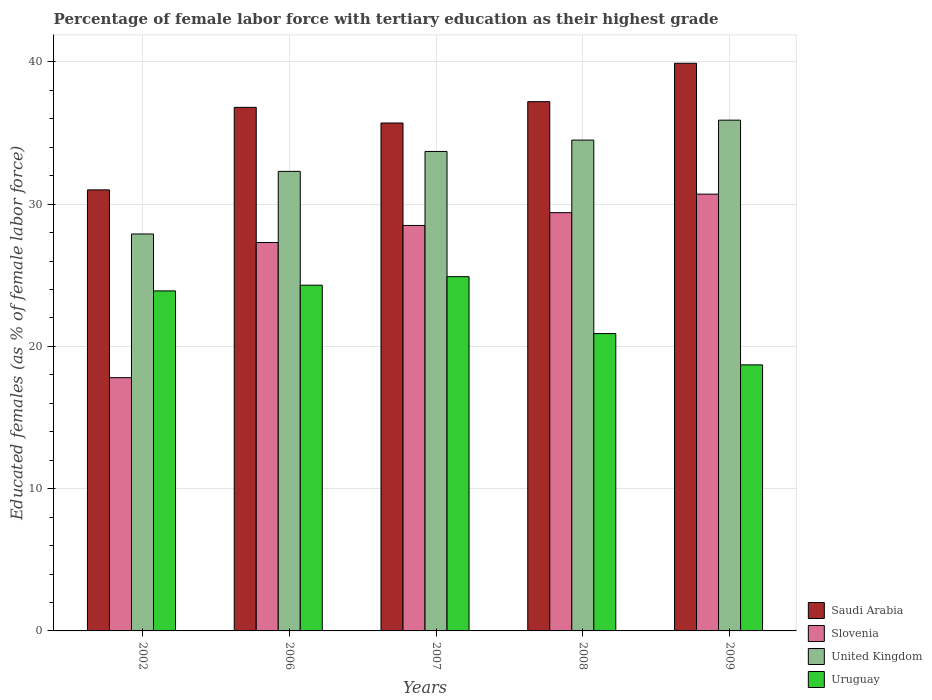How many groups of bars are there?
Provide a short and direct response. 5. Are the number of bars per tick equal to the number of legend labels?
Offer a terse response. Yes. What is the label of the 4th group of bars from the left?
Ensure brevity in your answer.  2008. What is the percentage of female labor force with tertiary education in Saudi Arabia in 2007?
Your answer should be compact. 35.7. Across all years, what is the maximum percentage of female labor force with tertiary education in Uruguay?
Your response must be concise. 24.9. In which year was the percentage of female labor force with tertiary education in United Kingdom maximum?
Provide a short and direct response. 2009. What is the total percentage of female labor force with tertiary education in Uruguay in the graph?
Offer a very short reply. 112.7. What is the difference between the percentage of female labor force with tertiary education in Saudi Arabia in 2007 and that in 2009?
Your response must be concise. -4.2. What is the difference between the percentage of female labor force with tertiary education in Saudi Arabia in 2008 and the percentage of female labor force with tertiary education in United Kingdom in 2006?
Give a very brief answer. 4.9. What is the average percentage of female labor force with tertiary education in Slovenia per year?
Ensure brevity in your answer.  26.74. What is the ratio of the percentage of female labor force with tertiary education in Uruguay in 2007 to that in 2008?
Offer a very short reply. 1.19. Is the percentage of female labor force with tertiary education in Uruguay in 2008 less than that in 2009?
Make the answer very short. No. Is the difference between the percentage of female labor force with tertiary education in Uruguay in 2006 and 2008 greater than the difference between the percentage of female labor force with tertiary education in United Kingdom in 2006 and 2008?
Make the answer very short. Yes. What is the difference between the highest and the second highest percentage of female labor force with tertiary education in Saudi Arabia?
Your answer should be very brief. 2.7. What is the difference between the highest and the lowest percentage of female labor force with tertiary education in United Kingdom?
Offer a very short reply. 8. What does the 2nd bar from the left in 2006 represents?
Provide a short and direct response. Slovenia. What does the 4th bar from the right in 2002 represents?
Provide a short and direct response. Saudi Arabia. Is it the case that in every year, the sum of the percentage of female labor force with tertiary education in Saudi Arabia and percentage of female labor force with tertiary education in Uruguay is greater than the percentage of female labor force with tertiary education in Slovenia?
Offer a very short reply. Yes. Are all the bars in the graph horizontal?
Provide a short and direct response. No. What is the difference between two consecutive major ticks on the Y-axis?
Ensure brevity in your answer.  10. Are the values on the major ticks of Y-axis written in scientific E-notation?
Your answer should be very brief. No. Does the graph contain grids?
Offer a very short reply. Yes. Where does the legend appear in the graph?
Keep it short and to the point. Bottom right. How are the legend labels stacked?
Your response must be concise. Vertical. What is the title of the graph?
Provide a short and direct response. Percentage of female labor force with tertiary education as their highest grade. Does "Marshall Islands" appear as one of the legend labels in the graph?
Offer a very short reply. No. What is the label or title of the Y-axis?
Make the answer very short. Educated females (as % of female labor force). What is the Educated females (as % of female labor force) of Saudi Arabia in 2002?
Your answer should be very brief. 31. What is the Educated females (as % of female labor force) of Slovenia in 2002?
Offer a very short reply. 17.8. What is the Educated females (as % of female labor force) of United Kingdom in 2002?
Offer a very short reply. 27.9. What is the Educated females (as % of female labor force) of Uruguay in 2002?
Your response must be concise. 23.9. What is the Educated females (as % of female labor force) in Saudi Arabia in 2006?
Keep it short and to the point. 36.8. What is the Educated females (as % of female labor force) in Slovenia in 2006?
Provide a succinct answer. 27.3. What is the Educated females (as % of female labor force) in United Kingdom in 2006?
Your answer should be very brief. 32.3. What is the Educated females (as % of female labor force) in Uruguay in 2006?
Make the answer very short. 24.3. What is the Educated females (as % of female labor force) of Saudi Arabia in 2007?
Ensure brevity in your answer.  35.7. What is the Educated females (as % of female labor force) of Slovenia in 2007?
Your answer should be compact. 28.5. What is the Educated females (as % of female labor force) of United Kingdom in 2007?
Provide a succinct answer. 33.7. What is the Educated females (as % of female labor force) of Uruguay in 2007?
Make the answer very short. 24.9. What is the Educated females (as % of female labor force) in Saudi Arabia in 2008?
Provide a succinct answer. 37.2. What is the Educated females (as % of female labor force) of Slovenia in 2008?
Your answer should be very brief. 29.4. What is the Educated females (as % of female labor force) of United Kingdom in 2008?
Provide a short and direct response. 34.5. What is the Educated females (as % of female labor force) of Uruguay in 2008?
Offer a very short reply. 20.9. What is the Educated females (as % of female labor force) in Saudi Arabia in 2009?
Your answer should be compact. 39.9. What is the Educated females (as % of female labor force) in Slovenia in 2009?
Your answer should be very brief. 30.7. What is the Educated females (as % of female labor force) of United Kingdom in 2009?
Keep it short and to the point. 35.9. What is the Educated females (as % of female labor force) in Uruguay in 2009?
Offer a terse response. 18.7. Across all years, what is the maximum Educated females (as % of female labor force) of Saudi Arabia?
Your response must be concise. 39.9. Across all years, what is the maximum Educated females (as % of female labor force) in Slovenia?
Provide a succinct answer. 30.7. Across all years, what is the maximum Educated females (as % of female labor force) in United Kingdom?
Provide a short and direct response. 35.9. Across all years, what is the maximum Educated females (as % of female labor force) in Uruguay?
Ensure brevity in your answer.  24.9. Across all years, what is the minimum Educated females (as % of female labor force) of Slovenia?
Offer a very short reply. 17.8. Across all years, what is the minimum Educated females (as % of female labor force) of United Kingdom?
Keep it short and to the point. 27.9. Across all years, what is the minimum Educated females (as % of female labor force) of Uruguay?
Offer a very short reply. 18.7. What is the total Educated females (as % of female labor force) in Saudi Arabia in the graph?
Offer a very short reply. 180.6. What is the total Educated females (as % of female labor force) in Slovenia in the graph?
Keep it short and to the point. 133.7. What is the total Educated females (as % of female labor force) in United Kingdom in the graph?
Offer a terse response. 164.3. What is the total Educated females (as % of female labor force) of Uruguay in the graph?
Ensure brevity in your answer.  112.7. What is the difference between the Educated females (as % of female labor force) in Saudi Arabia in 2002 and that in 2006?
Provide a short and direct response. -5.8. What is the difference between the Educated females (as % of female labor force) in Slovenia in 2002 and that in 2006?
Your answer should be compact. -9.5. What is the difference between the Educated females (as % of female labor force) in Uruguay in 2002 and that in 2006?
Give a very brief answer. -0.4. What is the difference between the Educated females (as % of female labor force) of Saudi Arabia in 2002 and that in 2007?
Provide a succinct answer. -4.7. What is the difference between the Educated females (as % of female labor force) in United Kingdom in 2002 and that in 2007?
Make the answer very short. -5.8. What is the difference between the Educated females (as % of female labor force) of United Kingdom in 2002 and that in 2008?
Offer a terse response. -6.6. What is the difference between the Educated females (as % of female labor force) of Uruguay in 2002 and that in 2008?
Your answer should be very brief. 3. What is the difference between the Educated females (as % of female labor force) of Saudi Arabia in 2006 and that in 2007?
Keep it short and to the point. 1.1. What is the difference between the Educated females (as % of female labor force) in Slovenia in 2006 and that in 2007?
Offer a terse response. -1.2. What is the difference between the Educated females (as % of female labor force) in United Kingdom in 2006 and that in 2008?
Offer a very short reply. -2.2. What is the difference between the Educated females (as % of female labor force) in Saudi Arabia in 2007 and that in 2008?
Offer a terse response. -1.5. What is the difference between the Educated females (as % of female labor force) in Slovenia in 2007 and that in 2008?
Your answer should be very brief. -0.9. What is the difference between the Educated females (as % of female labor force) of United Kingdom in 2007 and that in 2009?
Give a very brief answer. -2.2. What is the difference between the Educated females (as % of female labor force) of Uruguay in 2008 and that in 2009?
Keep it short and to the point. 2.2. What is the difference between the Educated females (as % of female labor force) in Saudi Arabia in 2002 and the Educated females (as % of female labor force) in Slovenia in 2006?
Make the answer very short. 3.7. What is the difference between the Educated females (as % of female labor force) of Saudi Arabia in 2002 and the Educated females (as % of female labor force) of United Kingdom in 2006?
Keep it short and to the point. -1.3. What is the difference between the Educated females (as % of female labor force) in United Kingdom in 2002 and the Educated females (as % of female labor force) in Uruguay in 2006?
Ensure brevity in your answer.  3.6. What is the difference between the Educated females (as % of female labor force) of Slovenia in 2002 and the Educated females (as % of female labor force) of United Kingdom in 2007?
Your response must be concise. -15.9. What is the difference between the Educated females (as % of female labor force) of Slovenia in 2002 and the Educated females (as % of female labor force) of Uruguay in 2007?
Provide a succinct answer. -7.1. What is the difference between the Educated females (as % of female labor force) in Saudi Arabia in 2002 and the Educated females (as % of female labor force) in Uruguay in 2008?
Provide a short and direct response. 10.1. What is the difference between the Educated females (as % of female labor force) in Slovenia in 2002 and the Educated females (as % of female labor force) in United Kingdom in 2008?
Provide a succinct answer. -16.7. What is the difference between the Educated females (as % of female labor force) of United Kingdom in 2002 and the Educated females (as % of female labor force) of Uruguay in 2008?
Make the answer very short. 7. What is the difference between the Educated females (as % of female labor force) of Slovenia in 2002 and the Educated females (as % of female labor force) of United Kingdom in 2009?
Ensure brevity in your answer.  -18.1. What is the difference between the Educated females (as % of female labor force) of Slovenia in 2002 and the Educated females (as % of female labor force) of Uruguay in 2009?
Provide a short and direct response. -0.9. What is the difference between the Educated females (as % of female labor force) in United Kingdom in 2002 and the Educated females (as % of female labor force) in Uruguay in 2009?
Keep it short and to the point. 9.2. What is the difference between the Educated females (as % of female labor force) in Saudi Arabia in 2006 and the Educated females (as % of female labor force) in Uruguay in 2007?
Your answer should be compact. 11.9. What is the difference between the Educated females (as % of female labor force) in Slovenia in 2006 and the Educated females (as % of female labor force) in Uruguay in 2007?
Give a very brief answer. 2.4. What is the difference between the Educated females (as % of female labor force) in Saudi Arabia in 2006 and the Educated females (as % of female labor force) in United Kingdom in 2008?
Your answer should be compact. 2.3. What is the difference between the Educated females (as % of female labor force) of Saudi Arabia in 2006 and the Educated females (as % of female labor force) of Uruguay in 2008?
Give a very brief answer. 15.9. What is the difference between the Educated females (as % of female labor force) of Slovenia in 2006 and the Educated females (as % of female labor force) of United Kingdom in 2008?
Offer a terse response. -7.2. What is the difference between the Educated females (as % of female labor force) of Slovenia in 2006 and the Educated females (as % of female labor force) of Uruguay in 2008?
Your answer should be compact. 6.4. What is the difference between the Educated females (as % of female labor force) in Saudi Arabia in 2006 and the Educated females (as % of female labor force) in United Kingdom in 2009?
Give a very brief answer. 0.9. What is the difference between the Educated females (as % of female labor force) in Slovenia in 2006 and the Educated females (as % of female labor force) in United Kingdom in 2009?
Make the answer very short. -8.6. What is the difference between the Educated females (as % of female labor force) of United Kingdom in 2006 and the Educated females (as % of female labor force) of Uruguay in 2009?
Give a very brief answer. 13.6. What is the difference between the Educated females (as % of female labor force) of Saudi Arabia in 2007 and the Educated females (as % of female labor force) of Slovenia in 2008?
Your answer should be very brief. 6.3. What is the difference between the Educated females (as % of female labor force) of Slovenia in 2007 and the Educated females (as % of female labor force) of United Kingdom in 2008?
Your answer should be compact. -6. What is the difference between the Educated females (as % of female labor force) in United Kingdom in 2007 and the Educated females (as % of female labor force) in Uruguay in 2008?
Make the answer very short. 12.8. What is the difference between the Educated females (as % of female labor force) of Saudi Arabia in 2007 and the Educated females (as % of female labor force) of Slovenia in 2009?
Give a very brief answer. 5. What is the difference between the Educated females (as % of female labor force) in Saudi Arabia in 2007 and the Educated females (as % of female labor force) in United Kingdom in 2009?
Offer a very short reply. -0.2. What is the difference between the Educated females (as % of female labor force) in Saudi Arabia in 2007 and the Educated females (as % of female labor force) in Uruguay in 2009?
Keep it short and to the point. 17. What is the difference between the Educated females (as % of female labor force) of Slovenia in 2007 and the Educated females (as % of female labor force) of United Kingdom in 2009?
Your answer should be compact. -7.4. What is the difference between the Educated females (as % of female labor force) in Slovenia in 2007 and the Educated females (as % of female labor force) in Uruguay in 2009?
Provide a succinct answer. 9.8. What is the difference between the Educated females (as % of female labor force) in Saudi Arabia in 2008 and the Educated females (as % of female labor force) in Slovenia in 2009?
Offer a very short reply. 6.5. What is the difference between the Educated females (as % of female labor force) of Saudi Arabia in 2008 and the Educated females (as % of female labor force) of United Kingdom in 2009?
Give a very brief answer. 1.3. What is the difference between the Educated females (as % of female labor force) of Saudi Arabia in 2008 and the Educated females (as % of female labor force) of Uruguay in 2009?
Offer a terse response. 18.5. What is the difference between the Educated females (as % of female labor force) of Slovenia in 2008 and the Educated females (as % of female labor force) of United Kingdom in 2009?
Provide a short and direct response. -6.5. What is the difference between the Educated females (as % of female labor force) in Slovenia in 2008 and the Educated females (as % of female labor force) in Uruguay in 2009?
Ensure brevity in your answer.  10.7. What is the difference between the Educated females (as % of female labor force) in United Kingdom in 2008 and the Educated females (as % of female labor force) in Uruguay in 2009?
Make the answer very short. 15.8. What is the average Educated females (as % of female labor force) of Saudi Arabia per year?
Keep it short and to the point. 36.12. What is the average Educated females (as % of female labor force) of Slovenia per year?
Offer a very short reply. 26.74. What is the average Educated females (as % of female labor force) of United Kingdom per year?
Give a very brief answer. 32.86. What is the average Educated females (as % of female labor force) of Uruguay per year?
Your response must be concise. 22.54. In the year 2002, what is the difference between the Educated females (as % of female labor force) of Saudi Arabia and Educated females (as % of female labor force) of Slovenia?
Offer a very short reply. 13.2. In the year 2002, what is the difference between the Educated females (as % of female labor force) of United Kingdom and Educated females (as % of female labor force) of Uruguay?
Make the answer very short. 4. In the year 2006, what is the difference between the Educated females (as % of female labor force) of Saudi Arabia and Educated females (as % of female labor force) of Uruguay?
Offer a very short reply. 12.5. In the year 2006, what is the difference between the Educated females (as % of female labor force) of Slovenia and Educated females (as % of female labor force) of Uruguay?
Make the answer very short. 3. In the year 2007, what is the difference between the Educated females (as % of female labor force) of Saudi Arabia and Educated females (as % of female labor force) of United Kingdom?
Offer a terse response. 2. In the year 2007, what is the difference between the Educated females (as % of female labor force) of Slovenia and Educated females (as % of female labor force) of United Kingdom?
Offer a terse response. -5.2. In the year 2007, what is the difference between the Educated females (as % of female labor force) of Slovenia and Educated females (as % of female labor force) of Uruguay?
Offer a terse response. 3.6. In the year 2007, what is the difference between the Educated females (as % of female labor force) in United Kingdom and Educated females (as % of female labor force) in Uruguay?
Your answer should be very brief. 8.8. In the year 2008, what is the difference between the Educated females (as % of female labor force) in Saudi Arabia and Educated females (as % of female labor force) in Slovenia?
Your answer should be very brief. 7.8. In the year 2008, what is the difference between the Educated females (as % of female labor force) of Slovenia and Educated females (as % of female labor force) of United Kingdom?
Provide a succinct answer. -5.1. In the year 2008, what is the difference between the Educated females (as % of female labor force) in United Kingdom and Educated females (as % of female labor force) in Uruguay?
Your answer should be very brief. 13.6. In the year 2009, what is the difference between the Educated females (as % of female labor force) in Saudi Arabia and Educated females (as % of female labor force) in United Kingdom?
Keep it short and to the point. 4. In the year 2009, what is the difference between the Educated females (as % of female labor force) of Saudi Arabia and Educated females (as % of female labor force) of Uruguay?
Give a very brief answer. 21.2. In the year 2009, what is the difference between the Educated females (as % of female labor force) of Slovenia and Educated females (as % of female labor force) of United Kingdom?
Offer a terse response. -5.2. In the year 2009, what is the difference between the Educated females (as % of female labor force) of United Kingdom and Educated females (as % of female labor force) of Uruguay?
Offer a terse response. 17.2. What is the ratio of the Educated females (as % of female labor force) in Saudi Arabia in 2002 to that in 2006?
Offer a terse response. 0.84. What is the ratio of the Educated females (as % of female labor force) in Slovenia in 2002 to that in 2006?
Give a very brief answer. 0.65. What is the ratio of the Educated females (as % of female labor force) of United Kingdom in 2002 to that in 2006?
Offer a very short reply. 0.86. What is the ratio of the Educated females (as % of female labor force) of Uruguay in 2002 to that in 2006?
Your answer should be very brief. 0.98. What is the ratio of the Educated females (as % of female labor force) of Saudi Arabia in 2002 to that in 2007?
Keep it short and to the point. 0.87. What is the ratio of the Educated females (as % of female labor force) of Slovenia in 2002 to that in 2007?
Your answer should be compact. 0.62. What is the ratio of the Educated females (as % of female labor force) in United Kingdom in 2002 to that in 2007?
Provide a short and direct response. 0.83. What is the ratio of the Educated females (as % of female labor force) of Uruguay in 2002 to that in 2007?
Your response must be concise. 0.96. What is the ratio of the Educated females (as % of female labor force) of Slovenia in 2002 to that in 2008?
Offer a terse response. 0.61. What is the ratio of the Educated females (as % of female labor force) in United Kingdom in 2002 to that in 2008?
Your answer should be compact. 0.81. What is the ratio of the Educated females (as % of female labor force) of Uruguay in 2002 to that in 2008?
Make the answer very short. 1.14. What is the ratio of the Educated females (as % of female labor force) of Saudi Arabia in 2002 to that in 2009?
Your answer should be compact. 0.78. What is the ratio of the Educated females (as % of female labor force) in Slovenia in 2002 to that in 2009?
Offer a terse response. 0.58. What is the ratio of the Educated females (as % of female labor force) in United Kingdom in 2002 to that in 2009?
Provide a short and direct response. 0.78. What is the ratio of the Educated females (as % of female labor force) in Uruguay in 2002 to that in 2009?
Offer a very short reply. 1.28. What is the ratio of the Educated females (as % of female labor force) in Saudi Arabia in 2006 to that in 2007?
Offer a very short reply. 1.03. What is the ratio of the Educated females (as % of female labor force) in Slovenia in 2006 to that in 2007?
Provide a succinct answer. 0.96. What is the ratio of the Educated females (as % of female labor force) of United Kingdom in 2006 to that in 2007?
Provide a succinct answer. 0.96. What is the ratio of the Educated females (as % of female labor force) in Uruguay in 2006 to that in 2007?
Give a very brief answer. 0.98. What is the ratio of the Educated females (as % of female labor force) of Saudi Arabia in 2006 to that in 2008?
Offer a very short reply. 0.99. What is the ratio of the Educated females (as % of female labor force) of United Kingdom in 2006 to that in 2008?
Your response must be concise. 0.94. What is the ratio of the Educated females (as % of female labor force) of Uruguay in 2006 to that in 2008?
Offer a terse response. 1.16. What is the ratio of the Educated females (as % of female labor force) of Saudi Arabia in 2006 to that in 2009?
Your response must be concise. 0.92. What is the ratio of the Educated females (as % of female labor force) in Slovenia in 2006 to that in 2009?
Provide a succinct answer. 0.89. What is the ratio of the Educated females (as % of female labor force) of United Kingdom in 2006 to that in 2009?
Provide a short and direct response. 0.9. What is the ratio of the Educated females (as % of female labor force) of Uruguay in 2006 to that in 2009?
Give a very brief answer. 1.3. What is the ratio of the Educated females (as % of female labor force) of Saudi Arabia in 2007 to that in 2008?
Your response must be concise. 0.96. What is the ratio of the Educated females (as % of female labor force) in Slovenia in 2007 to that in 2008?
Your answer should be very brief. 0.97. What is the ratio of the Educated females (as % of female labor force) of United Kingdom in 2007 to that in 2008?
Your answer should be compact. 0.98. What is the ratio of the Educated females (as % of female labor force) of Uruguay in 2007 to that in 2008?
Give a very brief answer. 1.19. What is the ratio of the Educated females (as % of female labor force) of Saudi Arabia in 2007 to that in 2009?
Offer a terse response. 0.89. What is the ratio of the Educated females (as % of female labor force) in Slovenia in 2007 to that in 2009?
Give a very brief answer. 0.93. What is the ratio of the Educated females (as % of female labor force) of United Kingdom in 2007 to that in 2009?
Ensure brevity in your answer.  0.94. What is the ratio of the Educated females (as % of female labor force) of Uruguay in 2007 to that in 2009?
Offer a terse response. 1.33. What is the ratio of the Educated females (as % of female labor force) in Saudi Arabia in 2008 to that in 2009?
Provide a succinct answer. 0.93. What is the ratio of the Educated females (as % of female labor force) in Slovenia in 2008 to that in 2009?
Provide a short and direct response. 0.96. What is the ratio of the Educated females (as % of female labor force) of United Kingdom in 2008 to that in 2009?
Keep it short and to the point. 0.96. What is the ratio of the Educated females (as % of female labor force) in Uruguay in 2008 to that in 2009?
Your answer should be very brief. 1.12. What is the difference between the highest and the second highest Educated females (as % of female labor force) of Saudi Arabia?
Provide a short and direct response. 2.7. What is the difference between the highest and the second highest Educated females (as % of female labor force) of United Kingdom?
Give a very brief answer. 1.4. What is the difference between the highest and the second highest Educated females (as % of female labor force) of Uruguay?
Keep it short and to the point. 0.6. What is the difference between the highest and the lowest Educated females (as % of female labor force) in Saudi Arabia?
Your response must be concise. 8.9. What is the difference between the highest and the lowest Educated females (as % of female labor force) in Slovenia?
Make the answer very short. 12.9. What is the difference between the highest and the lowest Educated females (as % of female labor force) of United Kingdom?
Offer a very short reply. 8. What is the difference between the highest and the lowest Educated females (as % of female labor force) in Uruguay?
Ensure brevity in your answer.  6.2. 